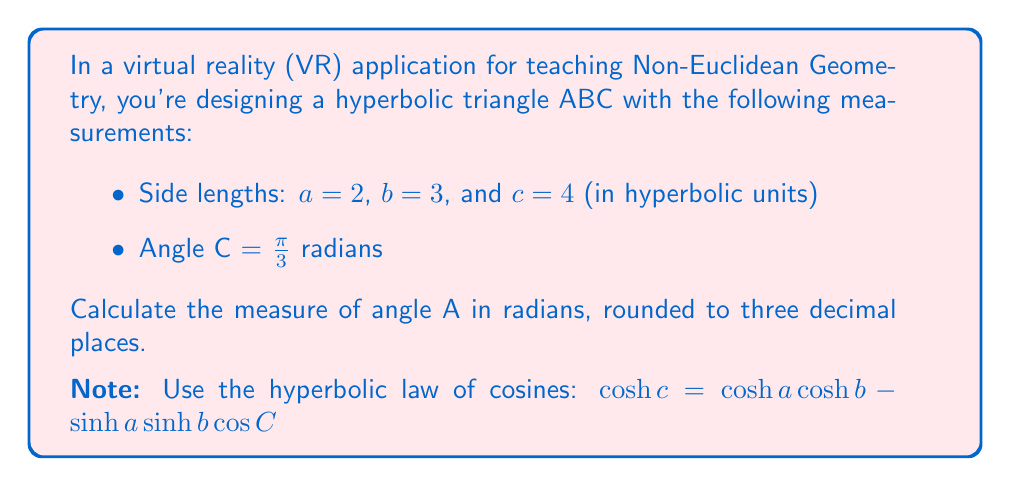Show me your answer to this math problem. To solve this problem, we'll use the hyperbolic law of cosines and follow these steps:

1) First, we'll use the given hyperbolic law of cosines to find $\cos A$:

   $\cosh b = \cosh c \cosh a - \sinh c \sinh a \cos A$

2) Rearrange the equation to isolate $\cos A$:

   $\cos A = \frac{\cosh c \cosh a - \cosh b}{\sinh c \sinh a}$

3) Calculate the hyperbolic functions for the given side lengths:

   $\cosh 2 = 3.7622$
   $\cosh 3 = 10.0677$
   $\cosh 4 = 27.3082$
   $\sinh 2 = 3.6269$
   $\sinh 3 = 10.0179$
   $\sinh 4 = 27.2899$

4) Substitute these values into the equation:

   $\cos A = \frac{27.3082 \cdot 3.7622 - 10.0677}{27.2899 \cdot 3.6269}$

5) Calculate:

   $\cos A = \frac{102.7415 - 10.0677}{98.9787} = 0.9367$

6) To find angle A, we need to take the inverse cosine (arccos):

   $A = \arccos(0.9367) = 0.3588$ radians

7) Round to three decimal places:

   $A \approx 0.359$ radians
Answer: $0.359$ radians 